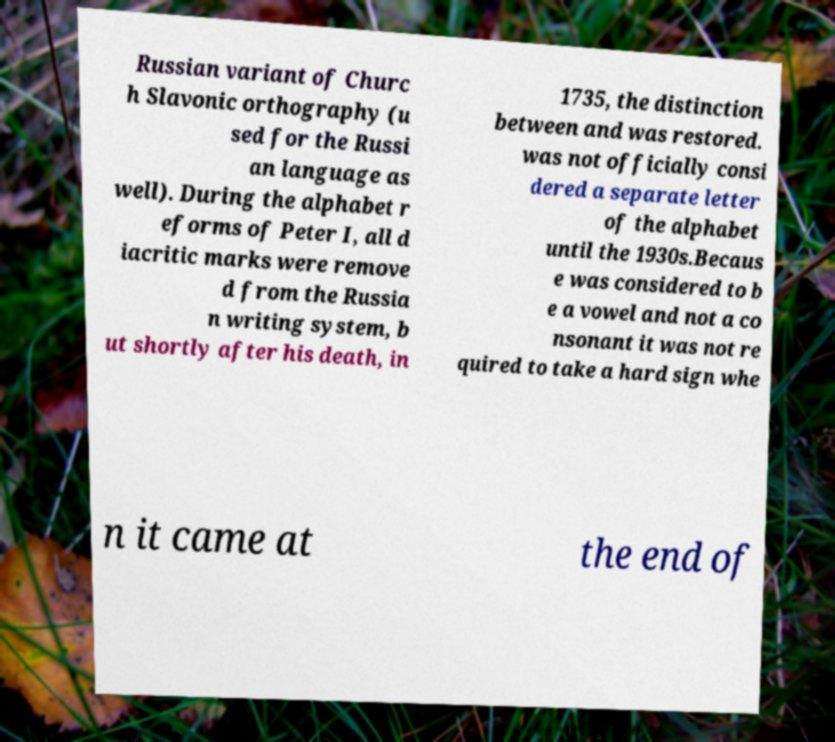I need the written content from this picture converted into text. Can you do that? Russian variant of Churc h Slavonic orthography (u sed for the Russi an language as well). During the alphabet r eforms of Peter I, all d iacritic marks were remove d from the Russia n writing system, b ut shortly after his death, in 1735, the distinction between and was restored. was not officially consi dered a separate letter of the alphabet until the 1930s.Becaus e was considered to b e a vowel and not a co nsonant it was not re quired to take a hard sign whe n it came at the end of 